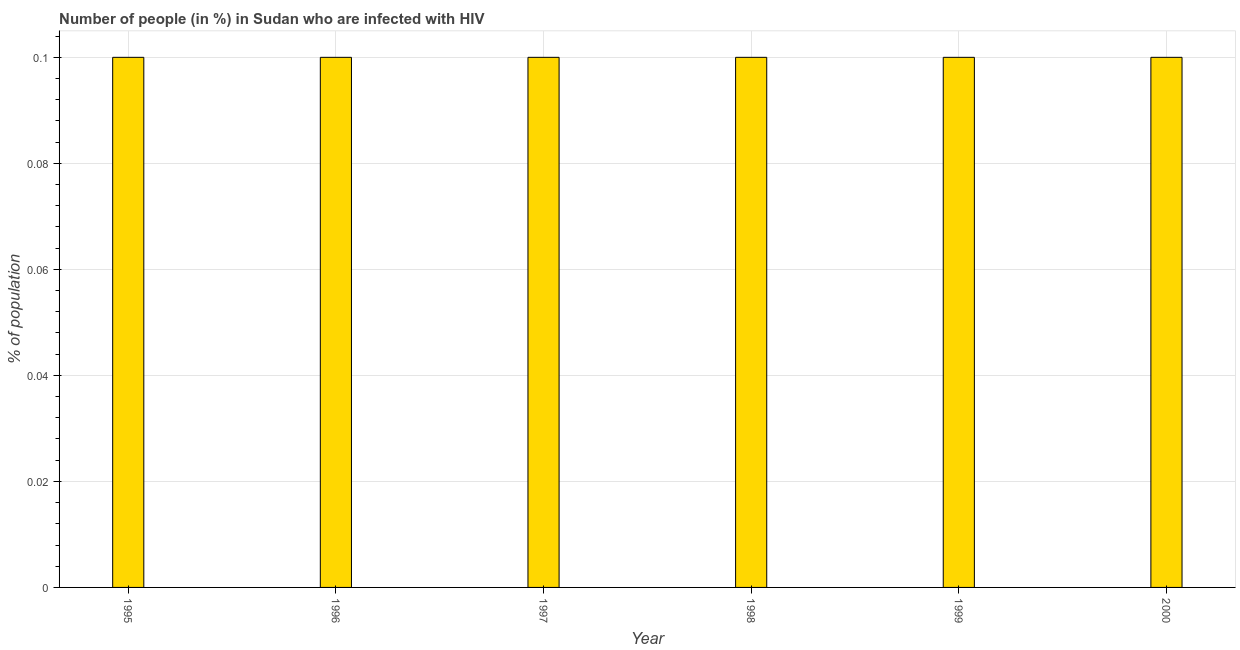Does the graph contain any zero values?
Provide a short and direct response. No. Does the graph contain grids?
Ensure brevity in your answer.  Yes. What is the title of the graph?
Your response must be concise. Number of people (in %) in Sudan who are infected with HIV. What is the label or title of the Y-axis?
Your answer should be very brief. % of population. What is the number of people infected with hiv in 1998?
Offer a very short reply. 0.1. Across all years, what is the maximum number of people infected with hiv?
Your answer should be compact. 0.1. Across all years, what is the minimum number of people infected with hiv?
Your response must be concise. 0.1. In which year was the number of people infected with hiv maximum?
Your answer should be very brief. 1995. In which year was the number of people infected with hiv minimum?
Your response must be concise. 1995. What is the difference between the number of people infected with hiv in 1996 and 2000?
Ensure brevity in your answer.  0. What is the median number of people infected with hiv?
Ensure brevity in your answer.  0.1. In how many years, is the number of people infected with hiv greater than the average number of people infected with hiv taken over all years?
Keep it short and to the point. 6. How many bars are there?
Provide a short and direct response. 6. How many years are there in the graph?
Provide a short and direct response. 6. Are the values on the major ticks of Y-axis written in scientific E-notation?
Give a very brief answer. No. What is the % of population in 1998?
Your answer should be compact. 0.1. What is the % of population of 1999?
Make the answer very short. 0.1. What is the difference between the % of population in 1995 and 1997?
Make the answer very short. 0. What is the difference between the % of population in 1995 and 1998?
Give a very brief answer. 0. What is the difference between the % of population in 1995 and 2000?
Provide a short and direct response. 0. What is the difference between the % of population in 1996 and 1997?
Your answer should be very brief. 0. What is the difference between the % of population in 1996 and 1998?
Provide a short and direct response. 0. What is the difference between the % of population in 1997 and 1998?
Provide a short and direct response. 0. What is the difference between the % of population in 1997 and 2000?
Your response must be concise. 0. What is the difference between the % of population in 1998 and 1999?
Your answer should be compact. 0. What is the difference between the % of population in 1998 and 2000?
Keep it short and to the point. 0. What is the ratio of the % of population in 1997 to that in 1998?
Provide a short and direct response. 1. What is the ratio of the % of population in 1997 to that in 1999?
Ensure brevity in your answer.  1. What is the ratio of the % of population in 1997 to that in 2000?
Give a very brief answer. 1. What is the ratio of the % of population in 1998 to that in 1999?
Offer a very short reply. 1. 